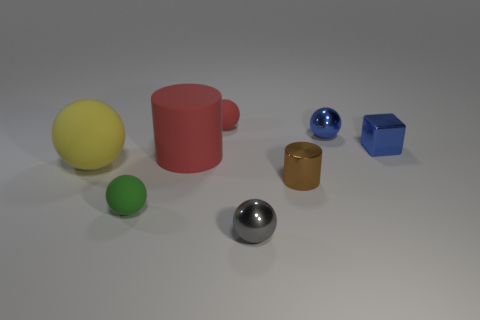Add 2 red cylinders. How many objects exist? 10 Subtract all small spheres. How many spheres are left? 1 Subtract all blue balls. How many balls are left? 4 Subtract all cylinders. How many objects are left? 6 Subtract 3 spheres. How many spheres are left? 2 Subtract all cyan cylinders. Subtract all yellow balls. How many cylinders are left? 2 Subtract all tiny cyan cylinders. Subtract all tiny blue things. How many objects are left? 6 Add 6 brown metal things. How many brown metal things are left? 7 Add 3 big brown rubber balls. How many big brown rubber balls exist? 3 Subtract 0 red blocks. How many objects are left? 8 